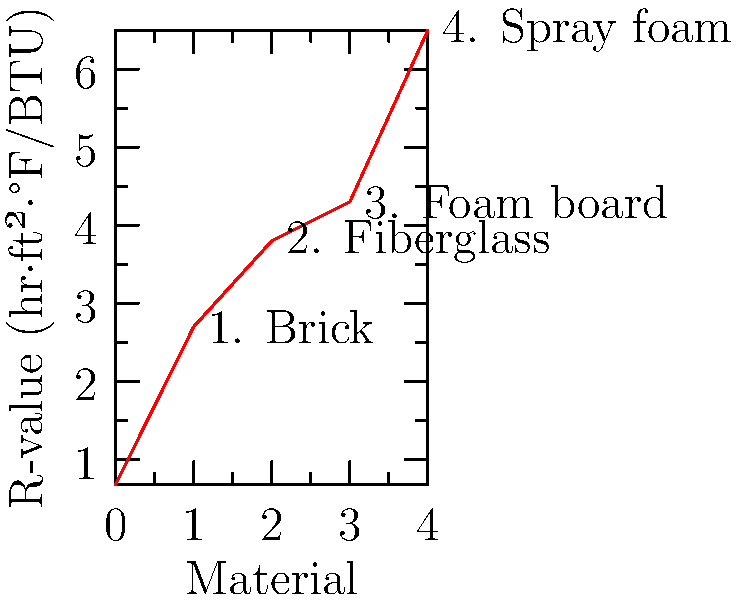Based on the graph showing R-values of various wall insulation materials, which material would be most effective for maintaining a comfortable sleeping temperature in a nurse's bedroom during daytime hours? To determine the most effective material for maintaining a comfortable sleeping temperature, we need to understand the concept of R-value and analyze the graph:

1. R-value measures thermal resistance: Higher R-value means better insulation.
2. The graph shows R-values for different materials:
   - Brick: R-value of 2.7
   - Fiberglass: R-value of 3.8
   - Foam board: R-value of 4.3
   - Spray foam: R-value of 6.5

3. The material with the highest R-value will provide the best thermal insulation.
4. Comparing the R-values:
   $6.5 > 4.3 > 3.8 > 2.7$

5. Spray foam has the highest R-value (6.5), making it the most effective insulator.

Therefore, spray foam would be the most effective material for maintaining a comfortable sleeping temperature in the nurse's bedroom during daytime hours.
Answer: Spray foam 